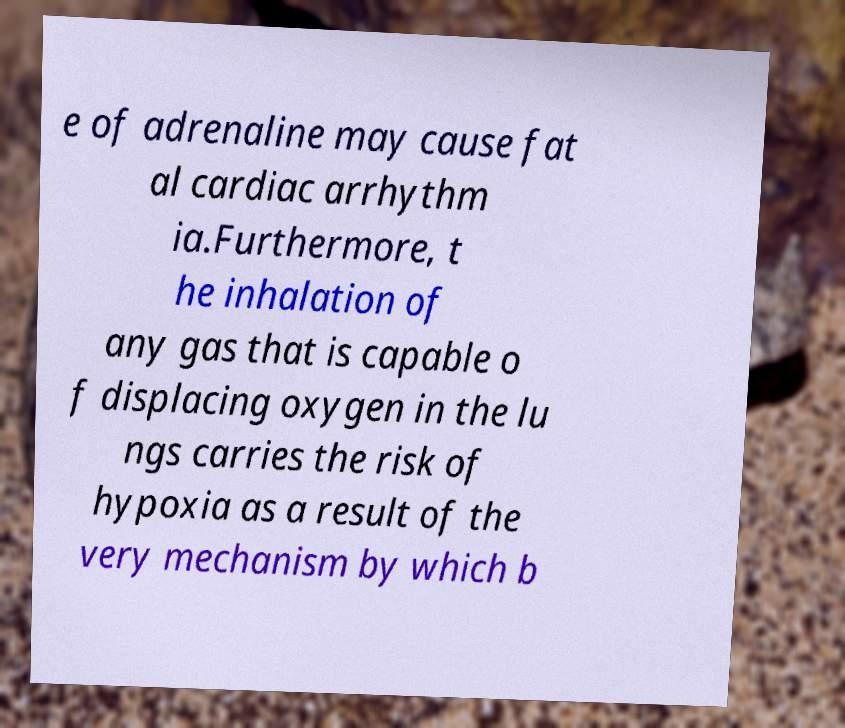Please read and relay the text visible in this image. What does it say? e of adrenaline may cause fat al cardiac arrhythm ia.Furthermore, t he inhalation of any gas that is capable o f displacing oxygen in the lu ngs carries the risk of hypoxia as a result of the very mechanism by which b 